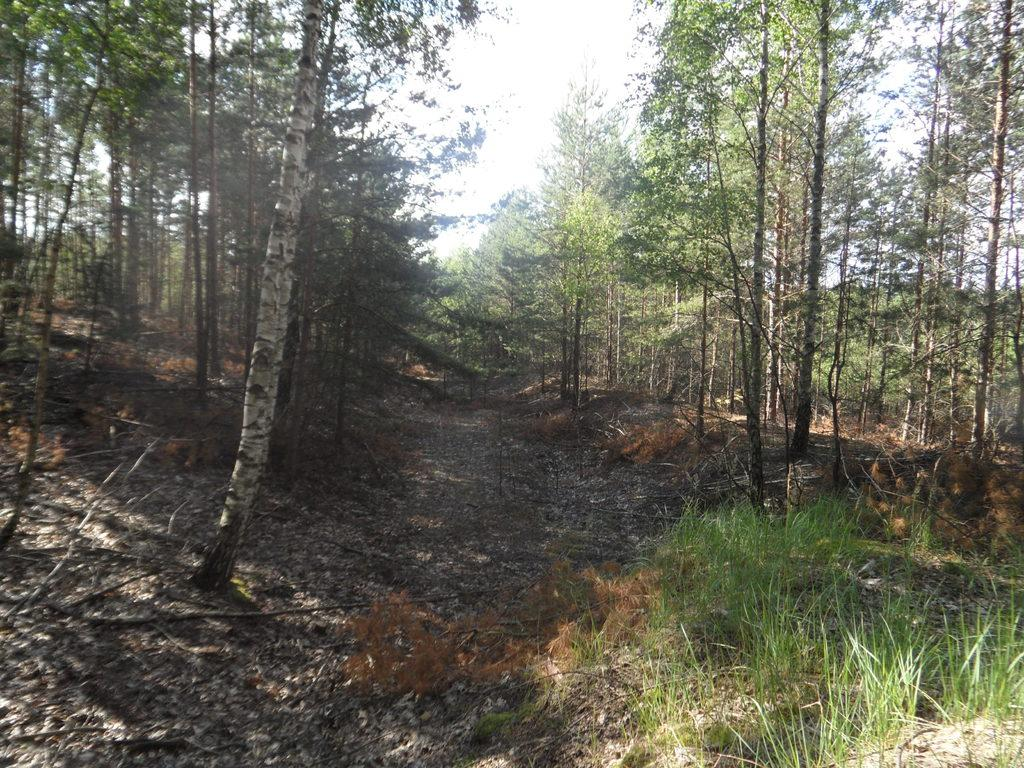What type of vegetation can be seen in the image? There are trees in the image. What is visible beneath the trees? The ground is visible in the image. What type of ground cover can be seen in some parts of the image? Some parts of the ground are covered with grass. What year is depicted in the image? The image does not depict a specific year; it is a photograph of a natural scene. 